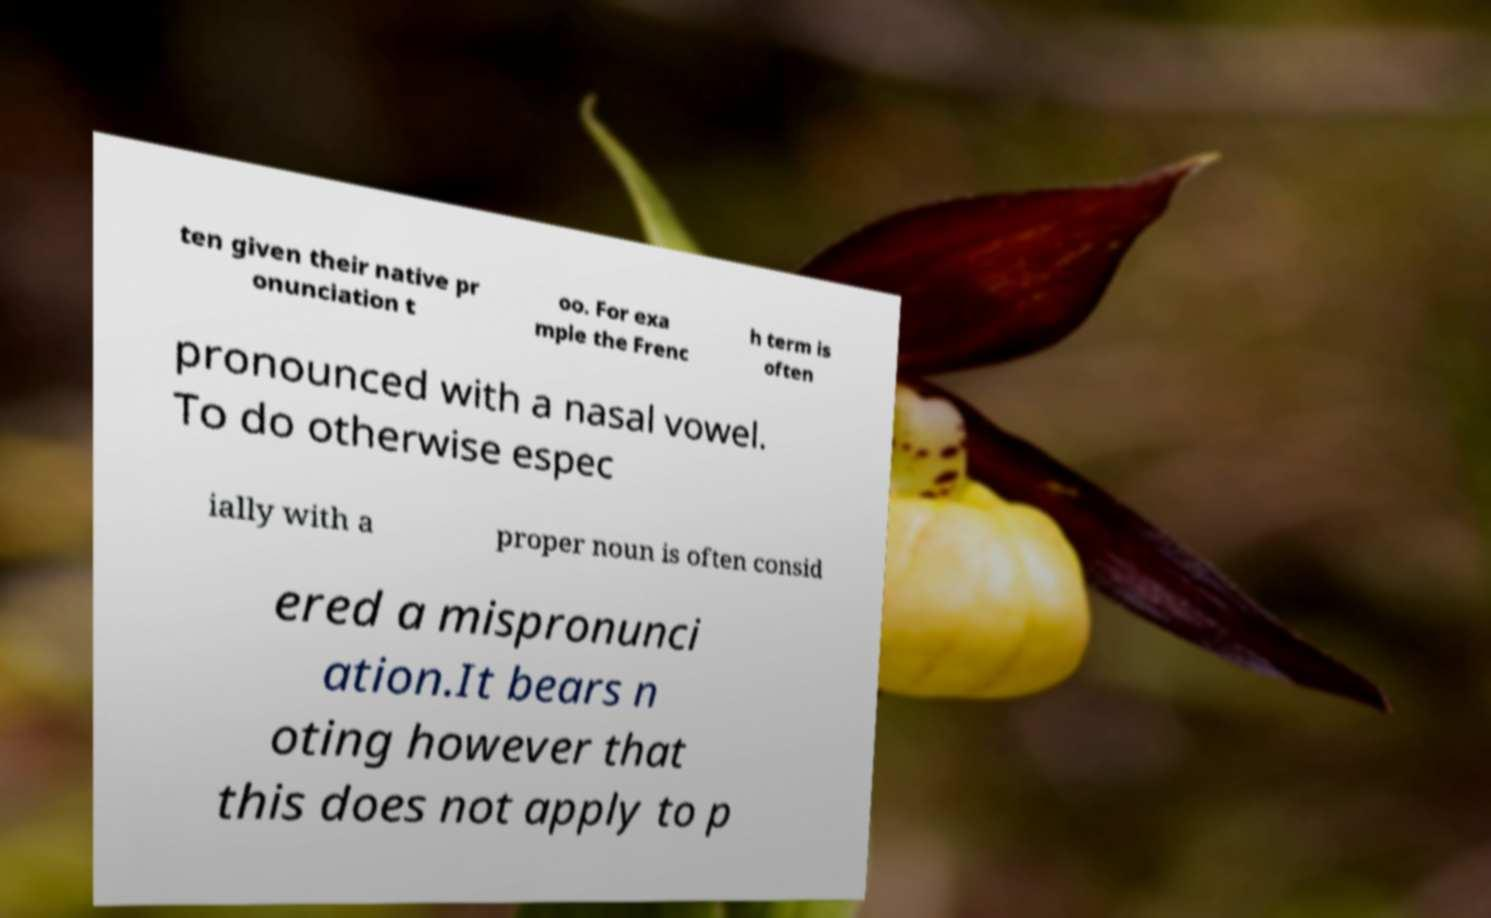Please identify and transcribe the text found in this image. ten given their native pr onunciation t oo. For exa mple the Frenc h term is often pronounced with a nasal vowel. To do otherwise espec ially with a proper noun is often consid ered a mispronunci ation.It bears n oting however that this does not apply to p 